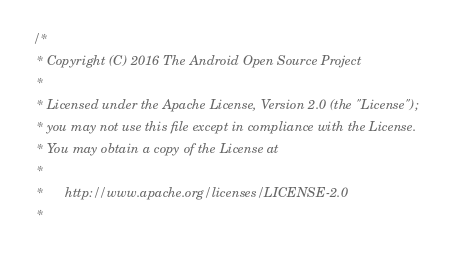<code> <loc_0><loc_0><loc_500><loc_500><_C++_>/*
 * Copyright (C) 2016 The Android Open Source Project
 *
 * Licensed under the Apache License, Version 2.0 (the "License");
 * you may not use this file except in compliance with the License.
 * You may obtain a copy of the License at
 *
 *      http://www.apache.org/licenses/LICENSE-2.0
 *</code> 